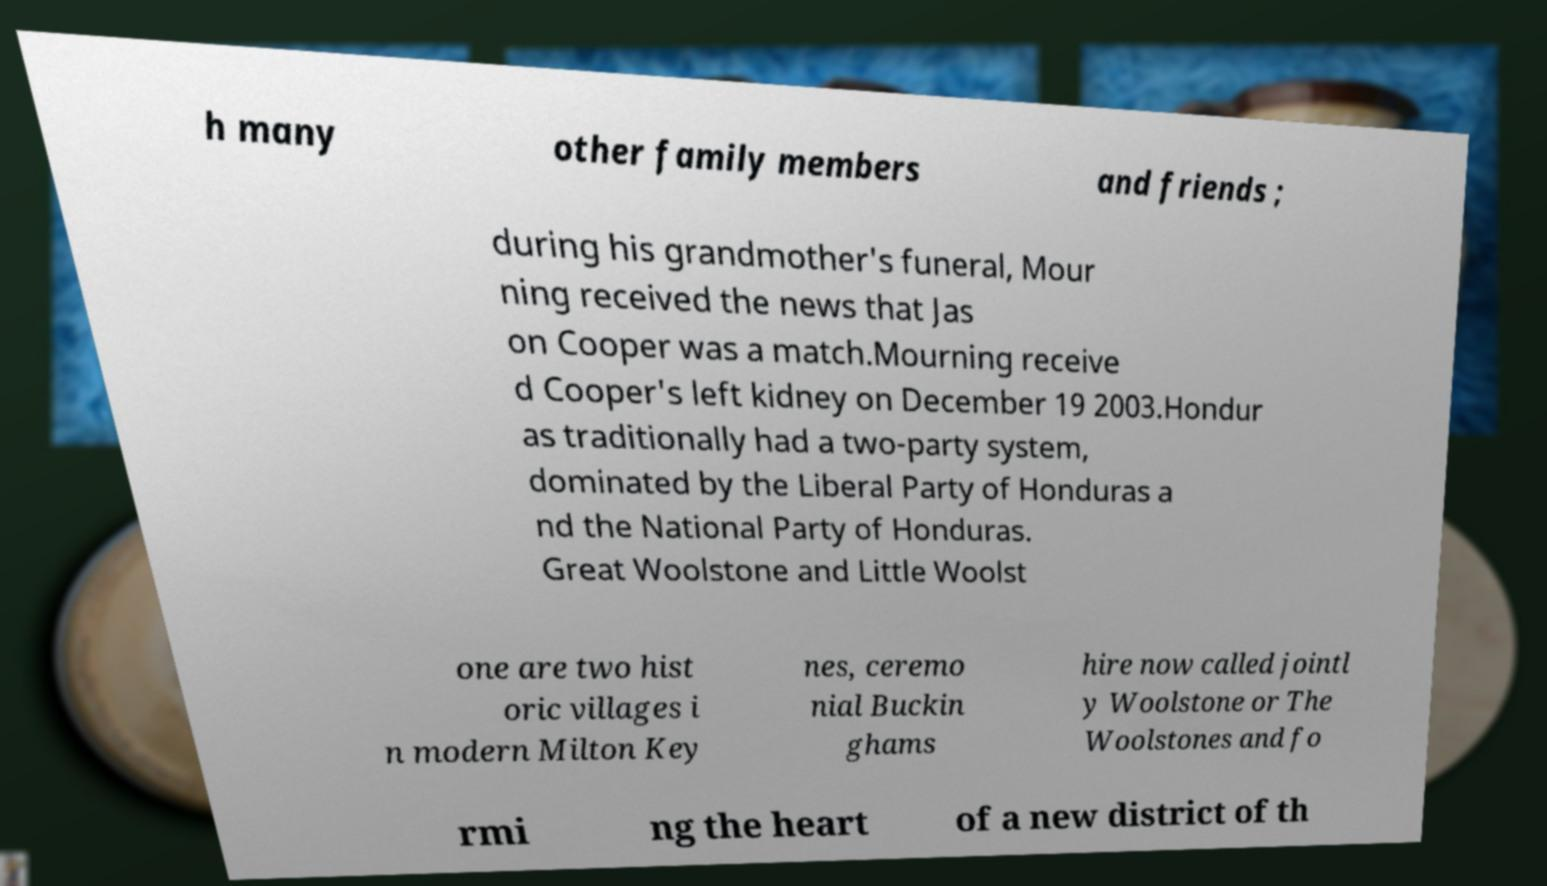Can you read and provide the text displayed in the image?This photo seems to have some interesting text. Can you extract and type it out for me? h many other family members and friends ; during his grandmother's funeral, Mour ning received the news that Jas on Cooper was a match.Mourning receive d Cooper's left kidney on December 19 2003.Hondur as traditionally had a two-party system, dominated by the Liberal Party of Honduras a nd the National Party of Honduras. Great Woolstone and Little Woolst one are two hist oric villages i n modern Milton Key nes, ceremo nial Buckin ghams hire now called jointl y Woolstone or The Woolstones and fo rmi ng the heart of a new district of th 